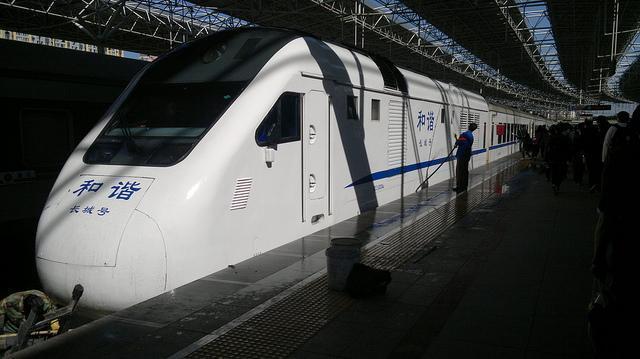How many red stripes are painted on the train?
Give a very brief answer. 0. 